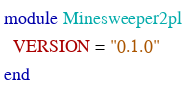Convert code to text. <code><loc_0><loc_0><loc_500><loc_500><_Ruby_>module Minesweeper2pl
  VERSION = "0.1.0"
end
</code> 